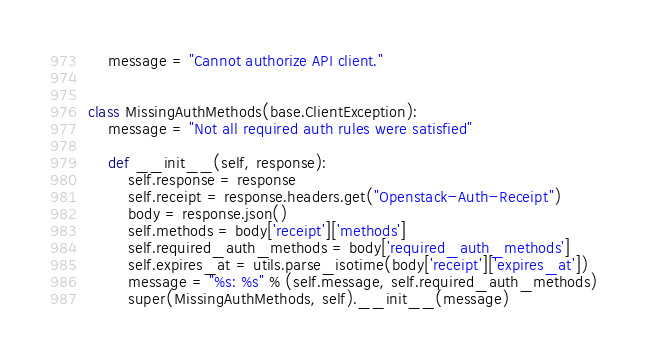Convert code to text. <code><loc_0><loc_0><loc_500><loc_500><_Python_>    message = "Cannot authorize API client."


class MissingAuthMethods(base.ClientException):
    message = "Not all required auth rules were satisfied"

    def __init__(self, response):
        self.response = response
        self.receipt = response.headers.get("Openstack-Auth-Receipt")
        body = response.json()
        self.methods = body['receipt']['methods']
        self.required_auth_methods = body['required_auth_methods']
        self.expires_at = utils.parse_isotime(body['receipt']['expires_at'])
        message = "%s: %s" % (self.message, self.required_auth_methods)
        super(MissingAuthMethods, self).__init__(message)
</code> 